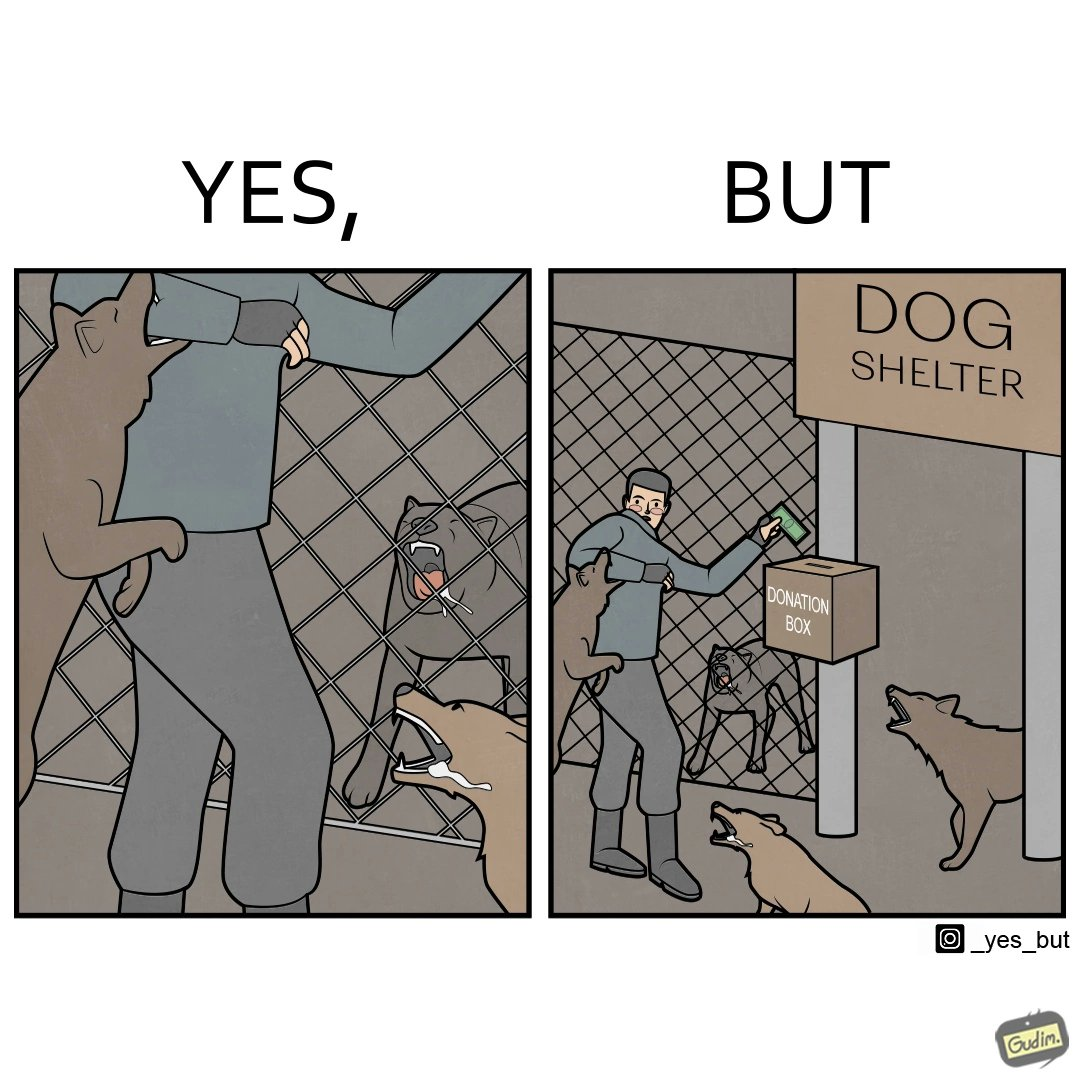Describe what you see in this image. The images are ironic since they show how dogs choose to attack a well wisher making a donation for helping dogs. It is sad that dogs mistake a well wisher and bite him while he is trying to help them. 